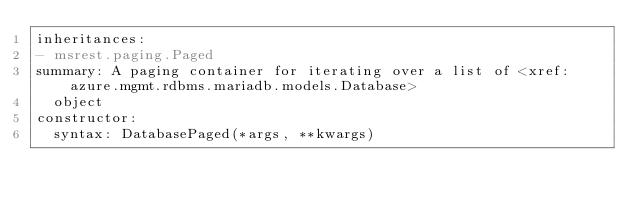Convert code to text. <code><loc_0><loc_0><loc_500><loc_500><_YAML_>inheritances:
- msrest.paging.Paged
summary: A paging container for iterating over a list of <xref:azure.mgmt.rdbms.mariadb.models.Database>
  object
constructor:
  syntax: DatabasePaged(*args, **kwargs)
</code> 